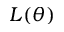<formula> <loc_0><loc_0><loc_500><loc_500>L ( \theta )</formula> 